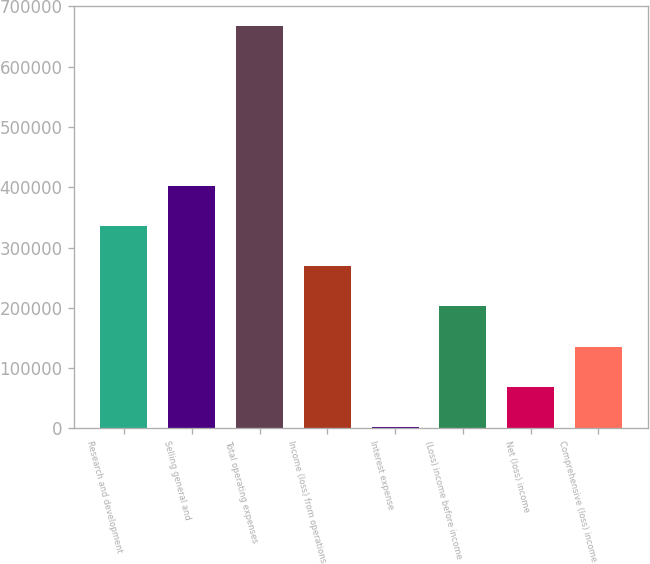<chart> <loc_0><loc_0><loc_500><loc_500><bar_chart><fcel>Research and development<fcel>Selling general and<fcel>Total operating expenses<fcel>Income (loss) from operations<fcel>Interest expense<fcel>(Loss) income before income<fcel>Net (loss) income<fcel>Comprehensive (loss) income<nl><fcel>335144<fcel>401567<fcel>667259<fcel>268721<fcel>3029<fcel>202298<fcel>69452<fcel>135875<nl></chart> 